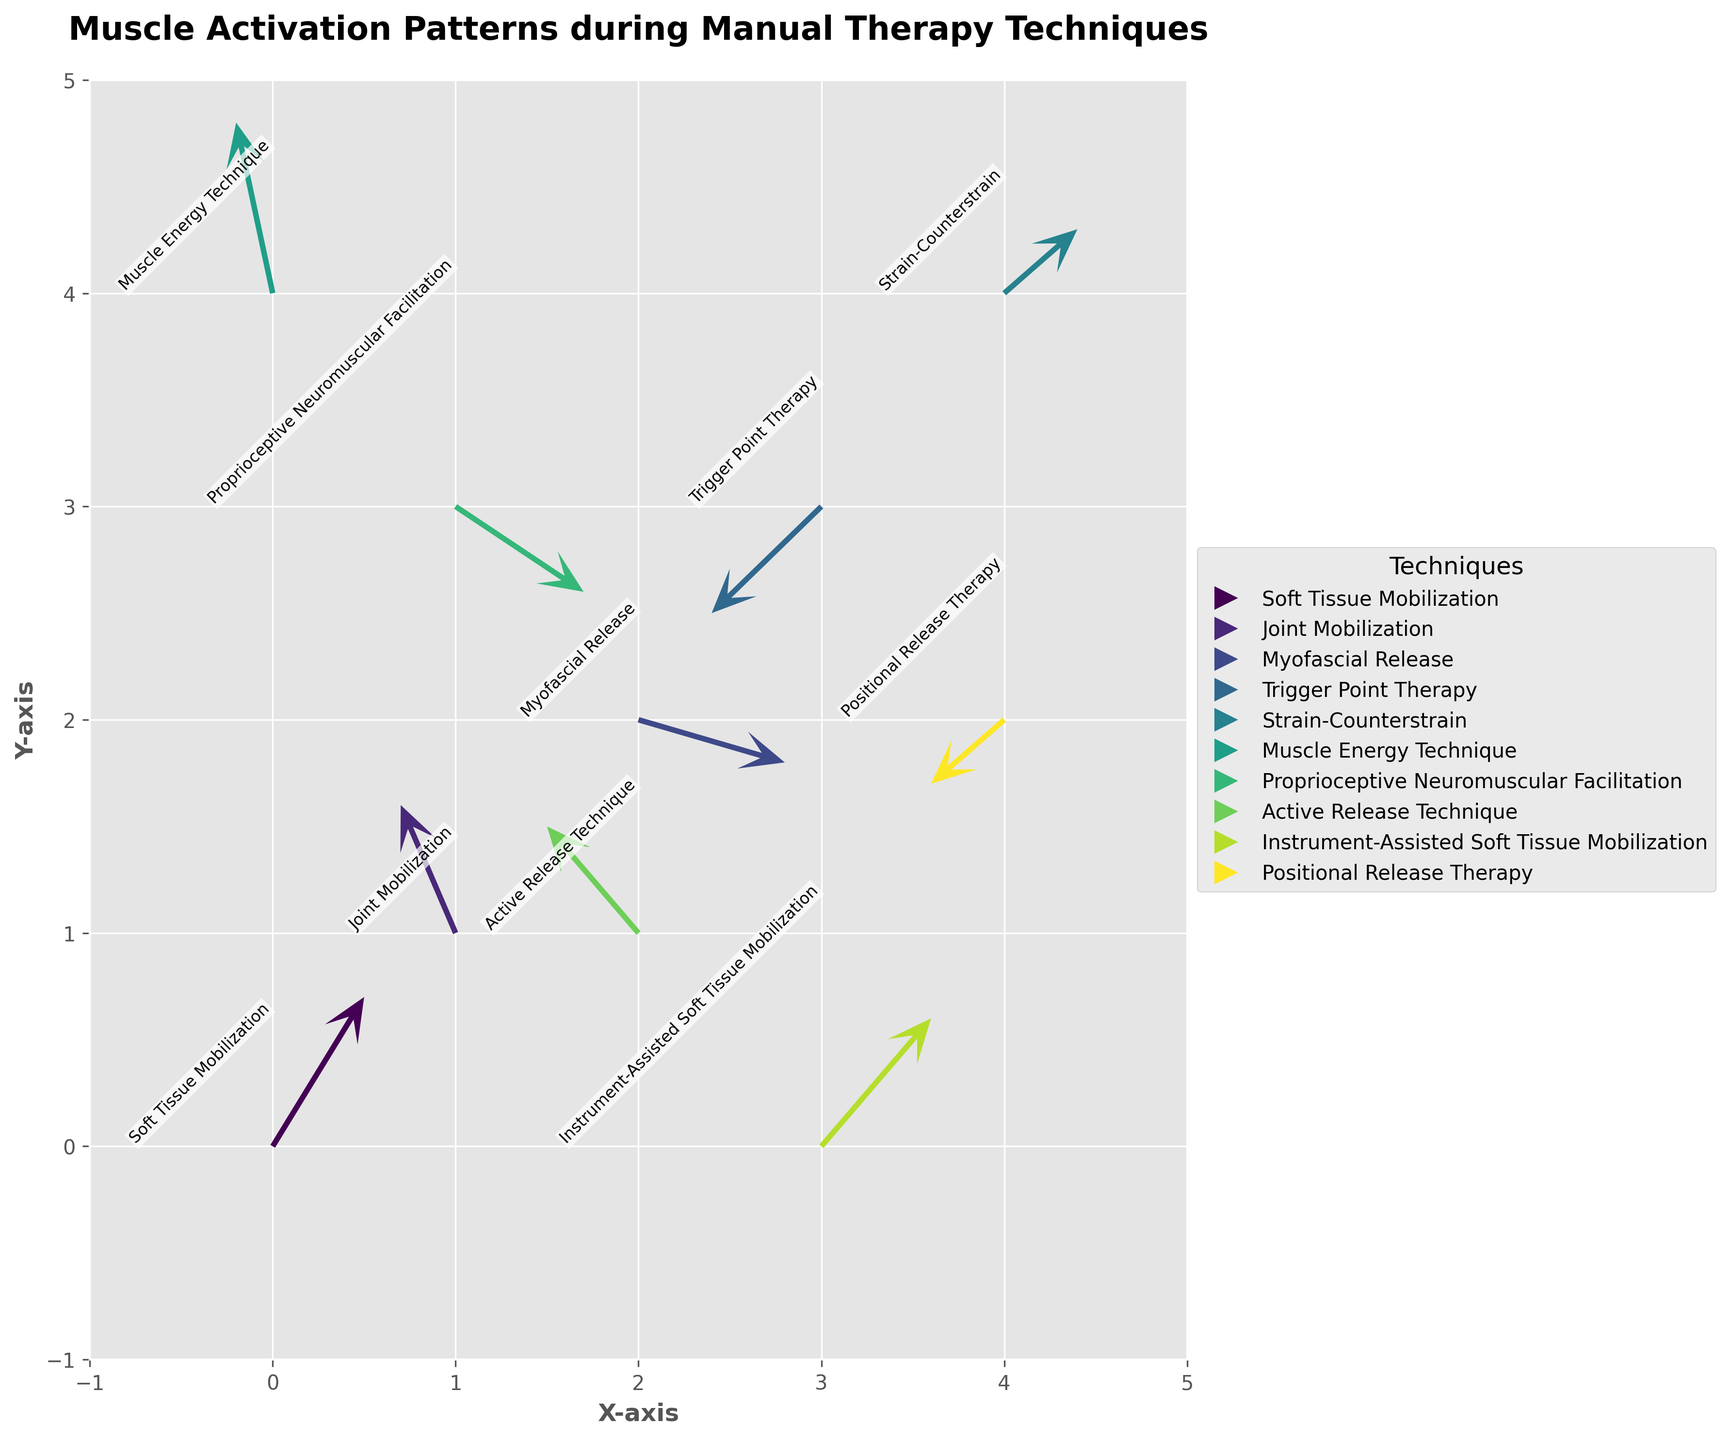What is the title of the figure? The title of the figure is displayed at the top of the plot. It reads "Muscle Activation Patterns during Manual Therapy Techniques".
Answer: Muscle Activation Patterns during Manual Therapy Techniques How many data points are shown in the figure? Count the number of arrows or quiver lines in the plot. Each arrow represents a single data point. There are 10 quiver lines in total.
Answer: 10 Which manual therapy technique has an arrow starting from the origin (0, 0)? Look at the arrows on the plot. The arrow that starts from coordinates (0, 0) is labeled "Soft Tissue Mobilization".
Answer: Soft Tissue Mobilization What is the direction of the arrow representing Joint Mobilization? Locate the arrow labeled "Joint Mobilization" which starts from (1, 1). The direction is given by the u and v components, where u = -0.3 and v = 0.6. This points it slightly leftward and upward.
Answer: slightly leftward and upward Which manual therapy technique has the second longest arrow? Visually inspect the plot for the lengths of the arrows. The second longest arrow appears to be "Active Release Technique" starting from (2, 1).
Answer: Active Release Technique What is the summed length of the arrows for Myofascial Release and Trigger Point Therapy? For each arrow, calculate the length using the formula √(u² + v²). For Myofascial Release (u = 0.8, v = -0.2), the length is √(0.8² + (-0.2)²) = √(0.64 + 0.04) ≈ 0.8246. For Trigger Point Therapy (u = -0.6, v = -0.5), the length is √((-0.6)² + (-0.5)²) = √(0.36 + 0.25) ≈ 0.7810. The total is 0.8246 + 0.7810 ≈ 1.6056.
Answer: 1.6056 Which technique shows muscle activation most aligned with the positive x-axis? Identify the arrow with the largest positive u component. Inspect the coordinates: the arrow starting from (2, 2) for Myofascial Release has u = 0.8, the largest positive.
Answer: Myofascial Release What is the difference in the vertical component (v) between Strain-Counterstrain and Positional Release Therapy? Check the v components for both techniques. Strain-Counterstrain has v = 0.3, and Positional Release Therapy has v = -0.3. The difference is 0.3 - (-0.3) = 0.6.
Answer: 0.6 Which technique has the largest horizontal component (u) moving towards the left? Identify the arrow with the largest negative u component. "Active Release Technique" with u = -0.5 has the largest negative horizontal movement.
Answer: Active Release Technique 